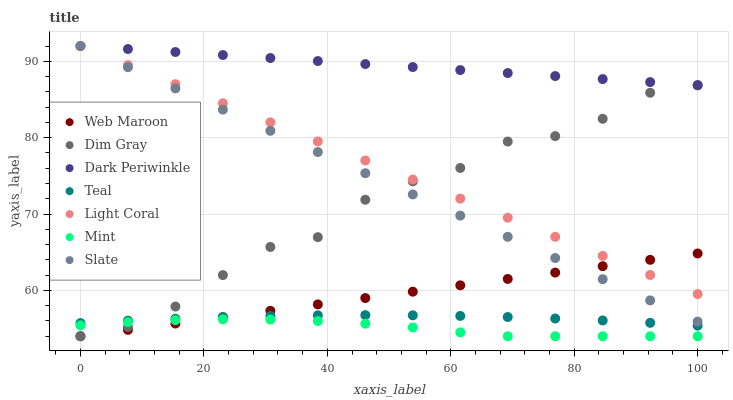Does Mint have the minimum area under the curve?
Answer yes or no. Yes. Does Dark Periwinkle have the maximum area under the curve?
Answer yes or no. Yes. Does Slate have the minimum area under the curve?
Answer yes or no. No. Does Slate have the maximum area under the curve?
Answer yes or no. No. Is Web Maroon the smoothest?
Answer yes or no. Yes. Is Dim Gray the roughest?
Answer yes or no. Yes. Is Slate the smoothest?
Answer yes or no. No. Is Slate the roughest?
Answer yes or no. No. Does Dim Gray have the lowest value?
Answer yes or no. Yes. Does Slate have the lowest value?
Answer yes or no. No. Does Dark Periwinkle have the highest value?
Answer yes or no. Yes. Does Web Maroon have the highest value?
Answer yes or no. No. Is Mint less than Slate?
Answer yes or no. Yes. Is Dark Periwinkle greater than Web Maroon?
Answer yes or no. Yes. Does Mint intersect Web Maroon?
Answer yes or no. Yes. Is Mint less than Web Maroon?
Answer yes or no. No. Is Mint greater than Web Maroon?
Answer yes or no. No. Does Mint intersect Slate?
Answer yes or no. No. 